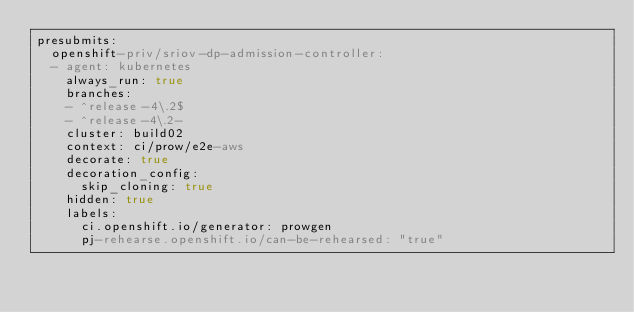<code> <loc_0><loc_0><loc_500><loc_500><_YAML_>presubmits:
  openshift-priv/sriov-dp-admission-controller:
  - agent: kubernetes
    always_run: true
    branches:
    - ^release-4\.2$
    - ^release-4\.2-
    cluster: build02
    context: ci/prow/e2e-aws
    decorate: true
    decoration_config:
      skip_cloning: true
    hidden: true
    labels:
      ci.openshift.io/generator: prowgen
      pj-rehearse.openshift.io/can-be-rehearsed: "true"</code> 